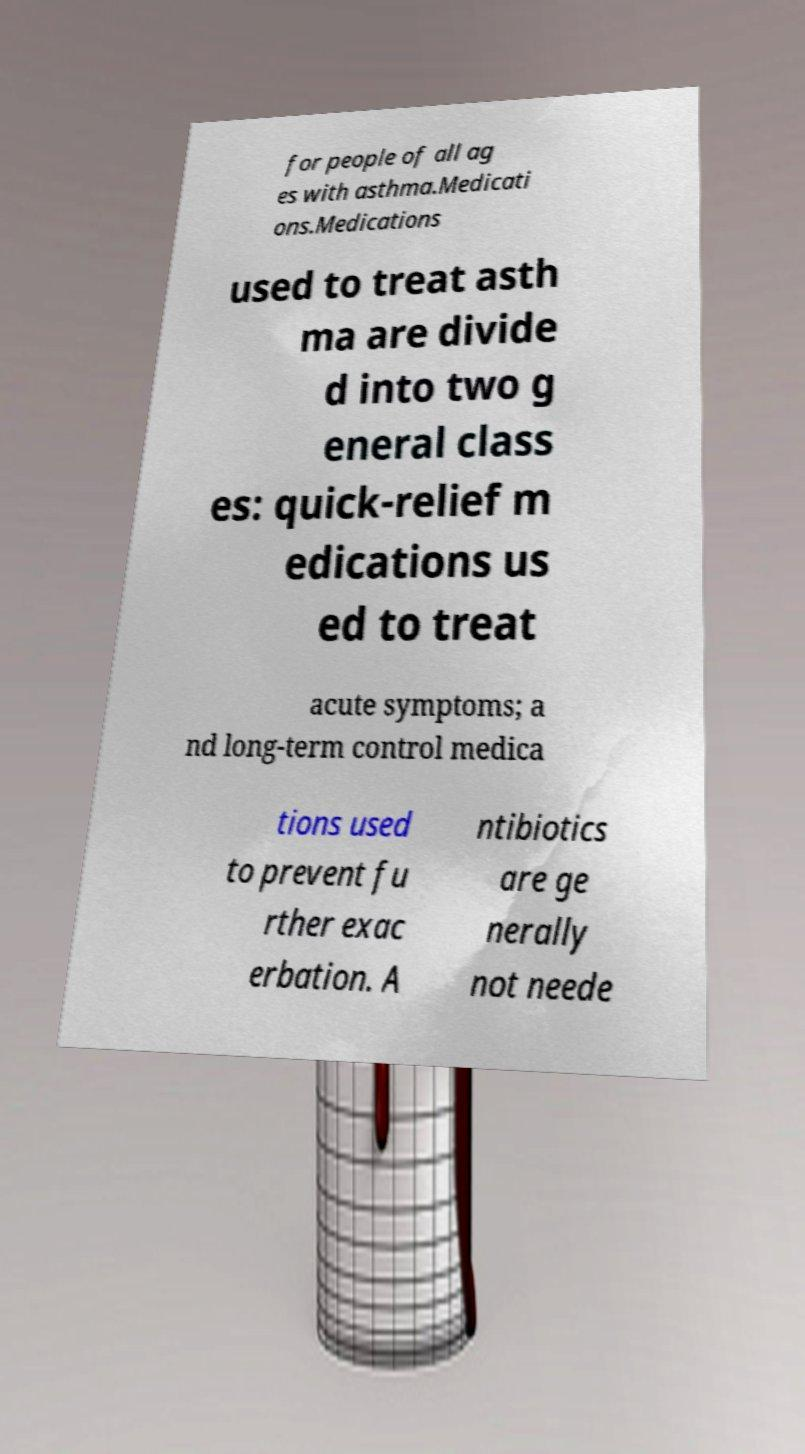Please read and relay the text visible in this image. What does it say? for people of all ag es with asthma.Medicati ons.Medications used to treat asth ma are divide d into two g eneral class es: quick-relief m edications us ed to treat acute symptoms; a nd long-term control medica tions used to prevent fu rther exac erbation. A ntibiotics are ge nerally not neede 